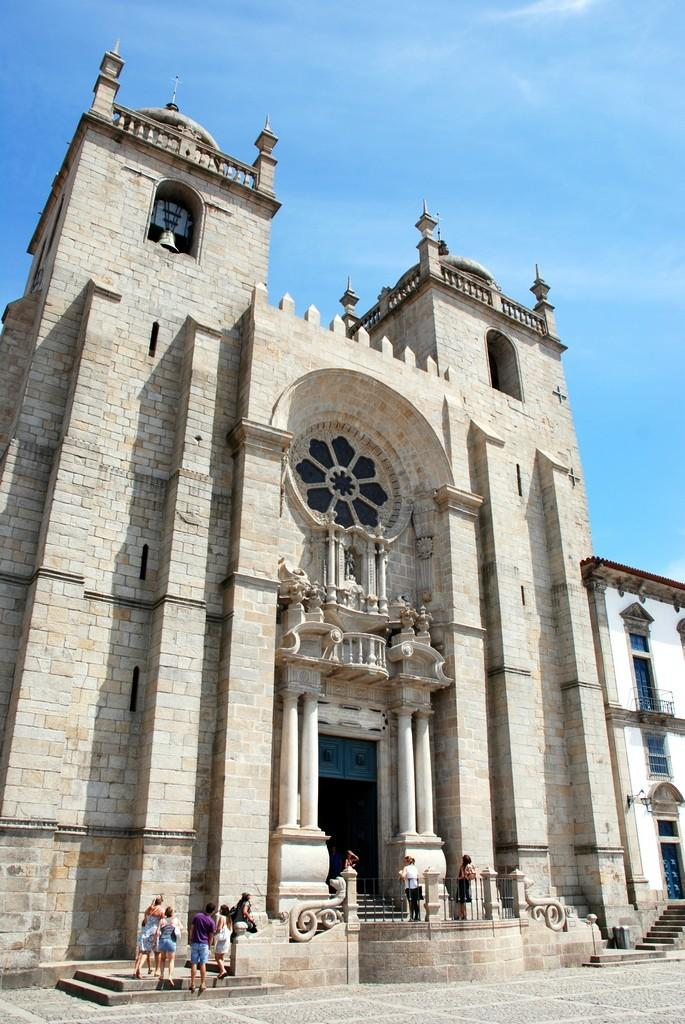What is located in the center of the image? There are buildings in the center of the image. Can you describe the people in the image? There are people in the image. What architectural feature is present in the image? There are stairs in the image. What can be seen in the background of the image? The sky is visible in the background of the image. How many dolls are sitting on the tramp in the image? There are no dolls or tramp present in the image. 